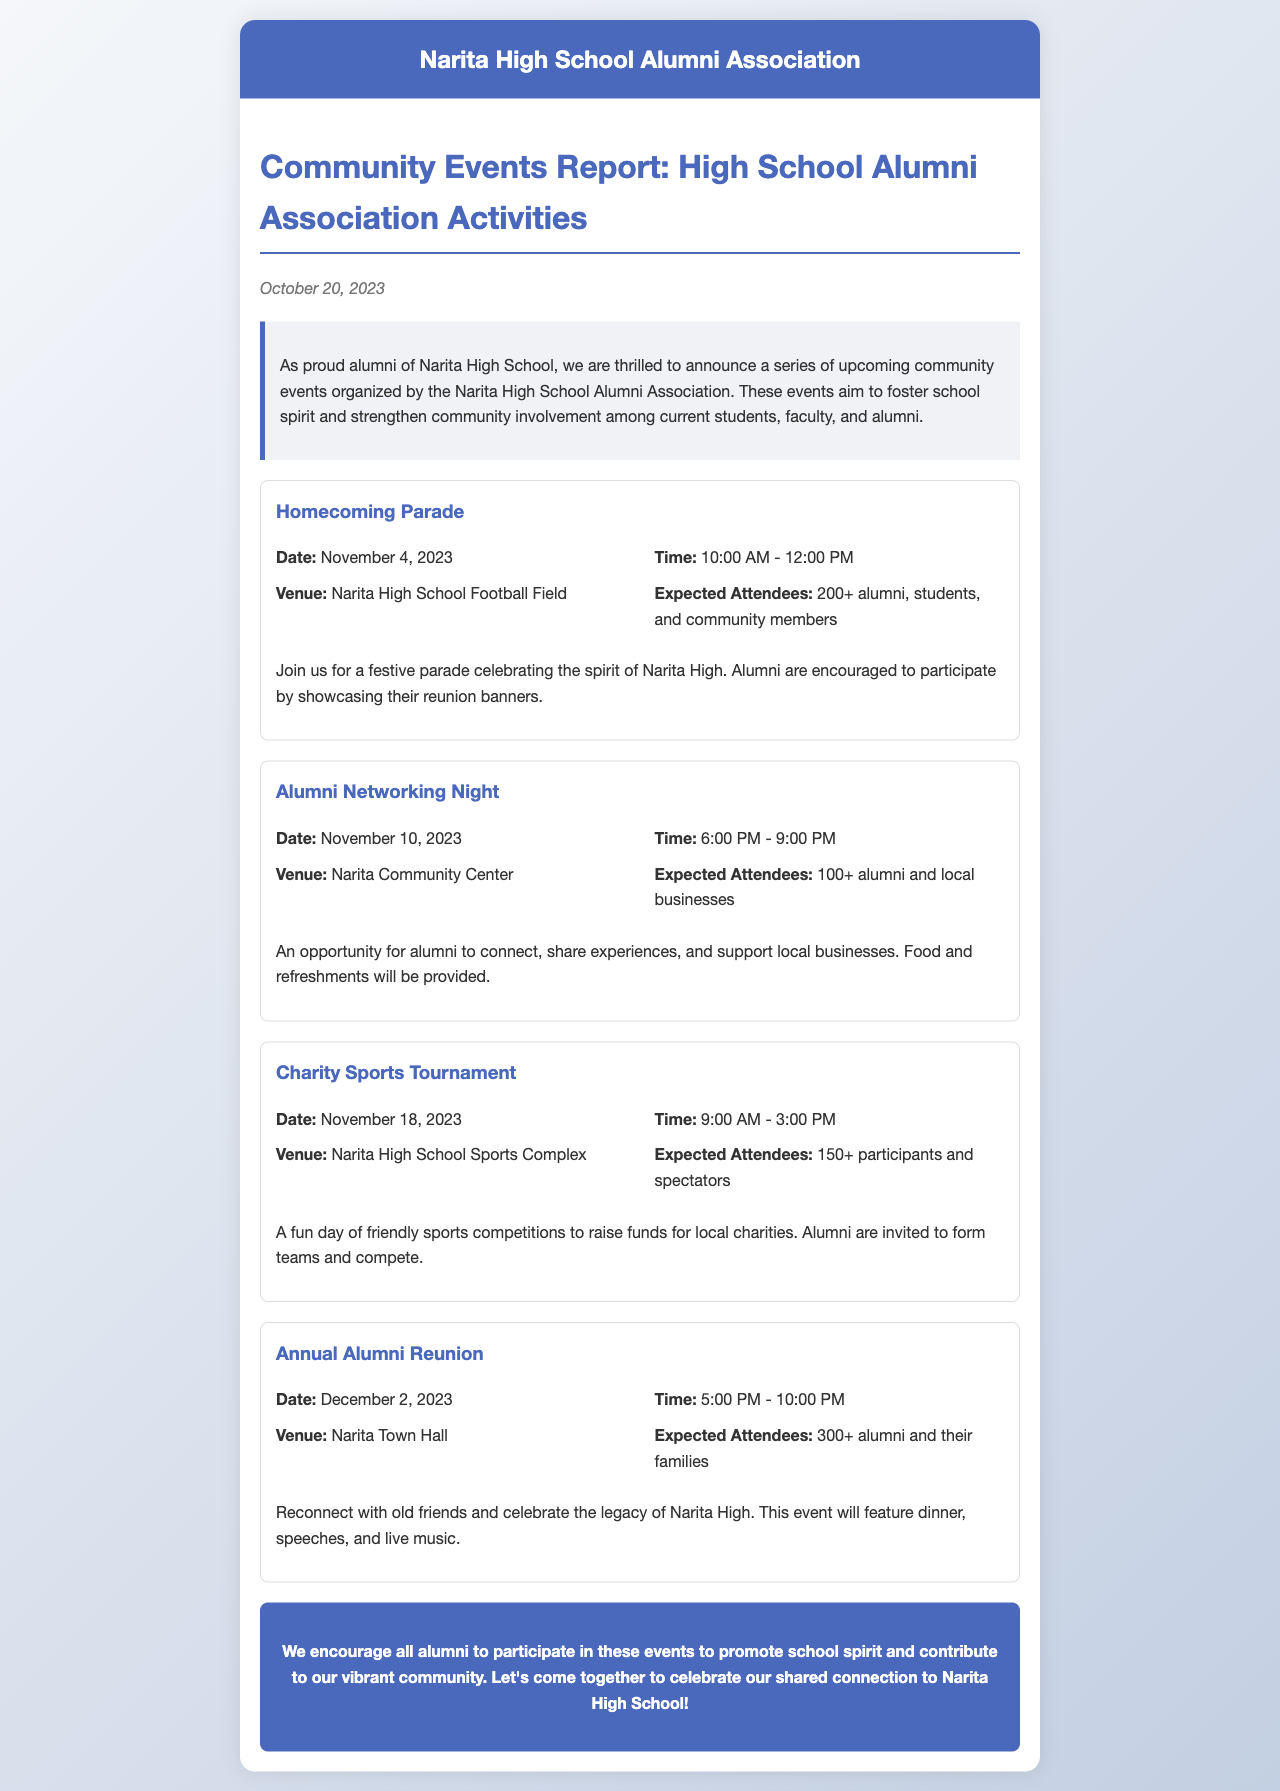What is the date of the Homecoming Parade? The Homecoming Parade is scheduled for November 4, 2023, as stated in the document.
Answer: November 4, 2023 How many expected attendees are there for the Annual Alumni Reunion? The document indicates that the Annual Alumni Reunion is expected to have 300+ attendees.
Answer: 300+ What time does the Alumni Networking Night start? The Alumni Networking Night is set to start at 6:00 PM according to the event details.
Answer: 6:00 PM Where is the venue for the Charity Sports Tournament? The document specifies the venue for the Charity Sports Tournament is the Narita High School Sports Complex.
Answer: Narita High School Sports Complex What type of activities are planned for the Homecoming Parade? The document mentions that the parade will celebrate the spirit of Narita High and encourages alumni to participate by showcasing their reunion banners.
Answer: Festive parade How many events are listed in the document? By counting all the events mentioned, there are a total of four events indicated in the document.
Answer: Four What is the purpose of the community events organized by the alumni association? The document states that the events aim to foster school spirit and strengthen community involvement.
Answer: Foster school spirit and strengthen community involvement What will be provided during the Alumni Networking Night? The document says food and refreshments will be provided at the Alumni Networking Night.
Answer: Food and refreshments 